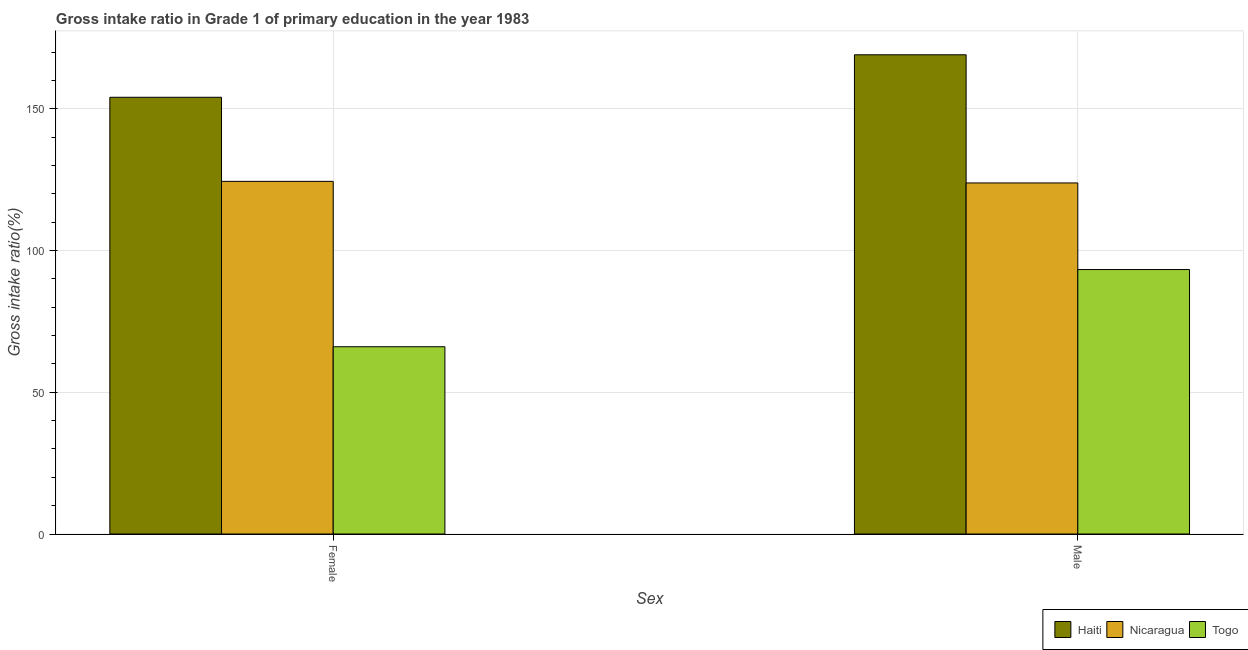Are the number of bars on each tick of the X-axis equal?
Provide a short and direct response. Yes. How many bars are there on the 1st tick from the right?
Keep it short and to the point. 3. What is the gross intake ratio(male) in Togo?
Offer a terse response. 93.33. Across all countries, what is the maximum gross intake ratio(female)?
Your response must be concise. 154.13. Across all countries, what is the minimum gross intake ratio(male)?
Provide a short and direct response. 93.33. In which country was the gross intake ratio(female) maximum?
Your answer should be very brief. Haiti. In which country was the gross intake ratio(male) minimum?
Your answer should be compact. Togo. What is the total gross intake ratio(female) in the graph?
Ensure brevity in your answer.  344.66. What is the difference between the gross intake ratio(male) in Haiti and that in Nicaragua?
Your response must be concise. 45.23. What is the difference between the gross intake ratio(male) in Nicaragua and the gross intake ratio(female) in Togo?
Ensure brevity in your answer.  57.81. What is the average gross intake ratio(female) per country?
Ensure brevity in your answer.  114.89. What is the difference between the gross intake ratio(male) and gross intake ratio(female) in Togo?
Offer a terse response. 27.25. In how many countries, is the gross intake ratio(male) greater than 10 %?
Keep it short and to the point. 3. What is the ratio of the gross intake ratio(female) in Haiti to that in Togo?
Your response must be concise. 2.33. What does the 3rd bar from the left in Female represents?
Ensure brevity in your answer.  Togo. What does the 2nd bar from the right in Female represents?
Offer a very short reply. Nicaragua. How many bars are there?
Your answer should be compact. 6. How many countries are there in the graph?
Ensure brevity in your answer.  3. What is the difference between two consecutive major ticks on the Y-axis?
Provide a succinct answer. 50. Does the graph contain any zero values?
Give a very brief answer. No. Does the graph contain grids?
Make the answer very short. Yes. How many legend labels are there?
Offer a terse response. 3. How are the legend labels stacked?
Your answer should be very brief. Horizontal. What is the title of the graph?
Your response must be concise. Gross intake ratio in Grade 1 of primary education in the year 1983. Does "Dominican Republic" appear as one of the legend labels in the graph?
Offer a very short reply. No. What is the label or title of the X-axis?
Keep it short and to the point. Sex. What is the label or title of the Y-axis?
Make the answer very short. Gross intake ratio(%). What is the Gross intake ratio(%) of Haiti in Female?
Keep it short and to the point. 154.13. What is the Gross intake ratio(%) of Nicaragua in Female?
Provide a succinct answer. 124.45. What is the Gross intake ratio(%) of Togo in Female?
Ensure brevity in your answer.  66.08. What is the Gross intake ratio(%) in Haiti in Male?
Make the answer very short. 169.12. What is the Gross intake ratio(%) of Nicaragua in Male?
Provide a succinct answer. 123.9. What is the Gross intake ratio(%) of Togo in Male?
Offer a very short reply. 93.33. Across all Sex, what is the maximum Gross intake ratio(%) of Haiti?
Keep it short and to the point. 169.12. Across all Sex, what is the maximum Gross intake ratio(%) in Nicaragua?
Give a very brief answer. 124.45. Across all Sex, what is the maximum Gross intake ratio(%) in Togo?
Provide a succinct answer. 93.33. Across all Sex, what is the minimum Gross intake ratio(%) of Haiti?
Provide a succinct answer. 154.13. Across all Sex, what is the minimum Gross intake ratio(%) of Nicaragua?
Keep it short and to the point. 123.9. Across all Sex, what is the minimum Gross intake ratio(%) of Togo?
Your answer should be compact. 66.08. What is the total Gross intake ratio(%) of Haiti in the graph?
Your answer should be compact. 323.25. What is the total Gross intake ratio(%) of Nicaragua in the graph?
Provide a succinct answer. 248.35. What is the total Gross intake ratio(%) in Togo in the graph?
Give a very brief answer. 159.42. What is the difference between the Gross intake ratio(%) of Haiti in Female and that in Male?
Offer a terse response. -14.99. What is the difference between the Gross intake ratio(%) of Nicaragua in Female and that in Male?
Offer a very short reply. 0.55. What is the difference between the Gross intake ratio(%) of Togo in Female and that in Male?
Provide a succinct answer. -27.25. What is the difference between the Gross intake ratio(%) of Haiti in Female and the Gross intake ratio(%) of Nicaragua in Male?
Keep it short and to the point. 30.23. What is the difference between the Gross intake ratio(%) of Haiti in Female and the Gross intake ratio(%) of Togo in Male?
Offer a very short reply. 60.8. What is the difference between the Gross intake ratio(%) in Nicaragua in Female and the Gross intake ratio(%) in Togo in Male?
Offer a terse response. 31.12. What is the average Gross intake ratio(%) in Haiti per Sex?
Your response must be concise. 161.63. What is the average Gross intake ratio(%) in Nicaragua per Sex?
Give a very brief answer. 124.17. What is the average Gross intake ratio(%) of Togo per Sex?
Your response must be concise. 79.71. What is the difference between the Gross intake ratio(%) of Haiti and Gross intake ratio(%) of Nicaragua in Female?
Your response must be concise. 29.68. What is the difference between the Gross intake ratio(%) of Haiti and Gross intake ratio(%) of Togo in Female?
Ensure brevity in your answer.  88.05. What is the difference between the Gross intake ratio(%) of Nicaragua and Gross intake ratio(%) of Togo in Female?
Your answer should be compact. 58.37. What is the difference between the Gross intake ratio(%) of Haiti and Gross intake ratio(%) of Nicaragua in Male?
Ensure brevity in your answer.  45.23. What is the difference between the Gross intake ratio(%) in Haiti and Gross intake ratio(%) in Togo in Male?
Ensure brevity in your answer.  75.79. What is the difference between the Gross intake ratio(%) of Nicaragua and Gross intake ratio(%) of Togo in Male?
Provide a succinct answer. 30.56. What is the ratio of the Gross intake ratio(%) in Haiti in Female to that in Male?
Offer a terse response. 0.91. What is the ratio of the Gross intake ratio(%) in Togo in Female to that in Male?
Offer a terse response. 0.71. What is the difference between the highest and the second highest Gross intake ratio(%) of Haiti?
Offer a terse response. 14.99. What is the difference between the highest and the second highest Gross intake ratio(%) of Nicaragua?
Make the answer very short. 0.55. What is the difference between the highest and the second highest Gross intake ratio(%) of Togo?
Keep it short and to the point. 27.25. What is the difference between the highest and the lowest Gross intake ratio(%) of Haiti?
Give a very brief answer. 14.99. What is the difference between the highest and the lowest Gross intake ratio(%) of Nicaragua?
Keep it short and to the point. 0.55. What is the difference between the highest and the lowest Gross intake ratio(%) of Togo?
Your answer should be compact. 27.25. 